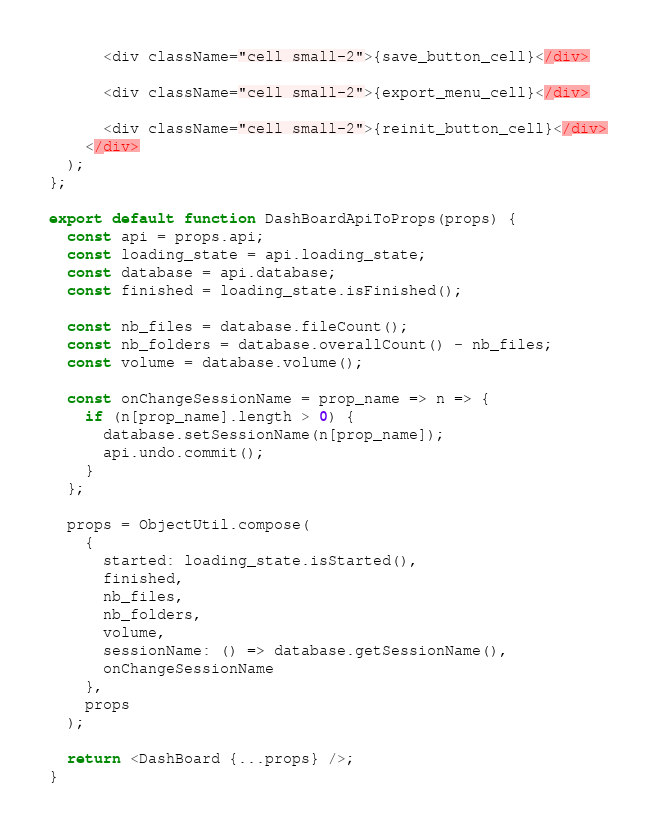Convert code to text. <code><loc_0><loc_0><loc_500><loc_500><_JavaScript_>      <div className="cell small-2">{save_button_cell}</div>

      <div className="cell small-2">{export_menu_cell}</div>

      <div className="cell small-2">{reinit_button_cell}</div>
    </div>
  );
};

export default function DashBoardApiToProps(props) {
  const api = props.api;
  const loading_state = api.loading_state;
  const database = api.database;
  const finished = loading_state.isFinished();

  const nb_files = database.fileCount();
  const nb_folders = database.overallCount() - nb_files;
  const volume = database.volume();

  const onChangeSessionName = prop_name => n => {
    if (n[prop_name].length > 0) {
      database.setSessionName(n[prop_name]);
      api.undo.commit();
    }
  };

  props = ObjectUtil.compose(
    {
      started: loading_state.isStarted(),
      finished,
      nb_files,
      nb_folders,
      volume,
      sessionName: () => database.getSessionName(),
      onChangeSessionName
    },
    props
  );

  return <DashBoard {...props} />;
}
</code> 